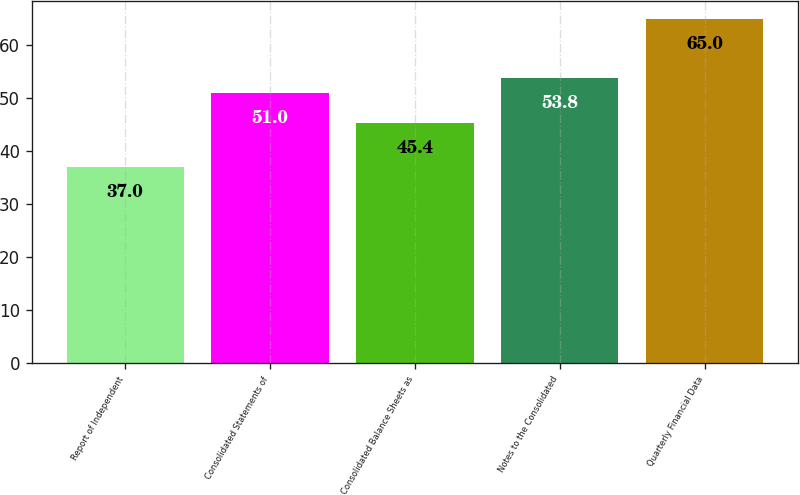Convert chart. <chart><loc_0><loc_0><loc_500><loc_500><bar_chart><fcel>Report of Independent<fcel>Consolidated Statements of<fcel>Consolidated Balance Sheets as<fcel>Notes to the Consolidated<fcel>Quarterly Financial Data<nl><fcel>37<fcel>51<fcel>45.4<fcel>53.8<fcel>65<nl></chart> 